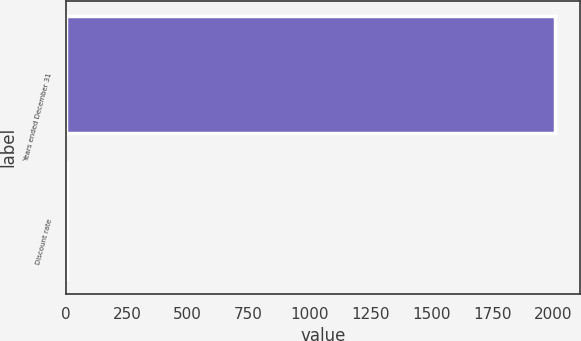<chart> <loc_0><loc_0><loc_500><loc_500><bar_chart><fcel>Years ended December 31<fcel>Discount rate<nl><fcel>2009<fcel>6.01<nl></chart> 